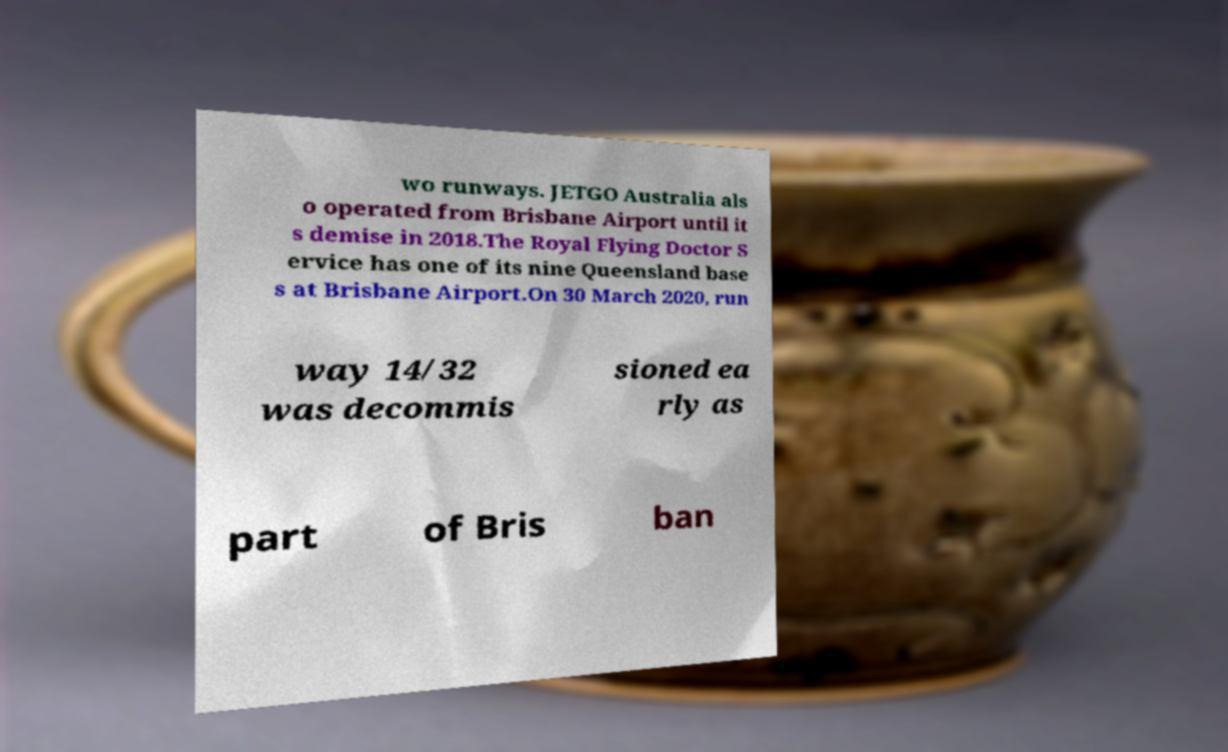What messages or text are displayed in this image? I need them in a readable, typed format. wo runways. JETGO Australia als o operated from Brisbane Airport until it s demise in 2018.The Royal Flying Doctor S ervice has one of its nine Queensland base s at Brisbane Airport.On 30 March 2020, run way 14/32 was decommis sioned ea rly as part of Bris ban 